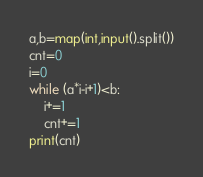<code> <loc_0><loc_0><loc_500><loc_500><_Python_>a,b=map(int,input().split())
cnt=0
i=0
while (a*i-i+1)<b:
    i+=1
    cnt+=1
print(cnt)</code> 